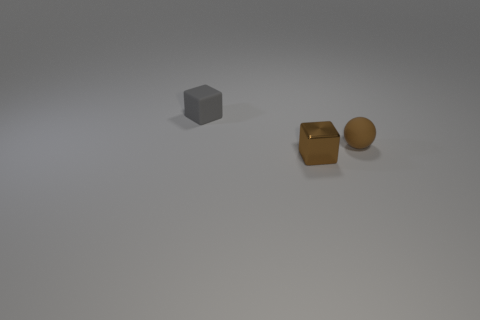Are any tiny brown spheres visible?
Ensure brevity in your answer.  Yes. What number of other things are there of the same size as the matte sphere?
Offer a terse response. 2. Is the gray block made of the same material as the small brown thing that is to the left of the sphere?
Your response must be concise. No. Are there the same number of small things that are in front of the small brown sphere and tiny rubber blocks that are in front of the tiny brown metal block?
Ensure brevity in your answer.  No. What material is the tiny gray thing?
Give a very brief answer. Rubber. What is the color of the rubber ball that is the same size as the metal object?
Provide a short and direct response. Brown. There is a block in front of the tiny gray block; are there any small cubes that are right of it?
Make the answer very short. No. How many blocks are either brown objects or small metallic things?
Offer a terse response. 1. There is a cube that is to the left of the cube in front of the cube that is behind the tiny brown ball; what is its size?
Your answer should be compact. Small. Are there any brown cubes on the left side of the small gray rubber block?
Your answer should be very brief. No. 